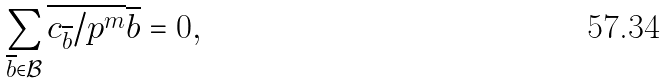<formula> <loc_0><loc_0><loc_500><loc_500>\sum _ { \overline { b } \in \mathcal { B } } \overline { c _ { \overline { b } } / p ^ { m } } \overline { b } = 0 ,</formula> 